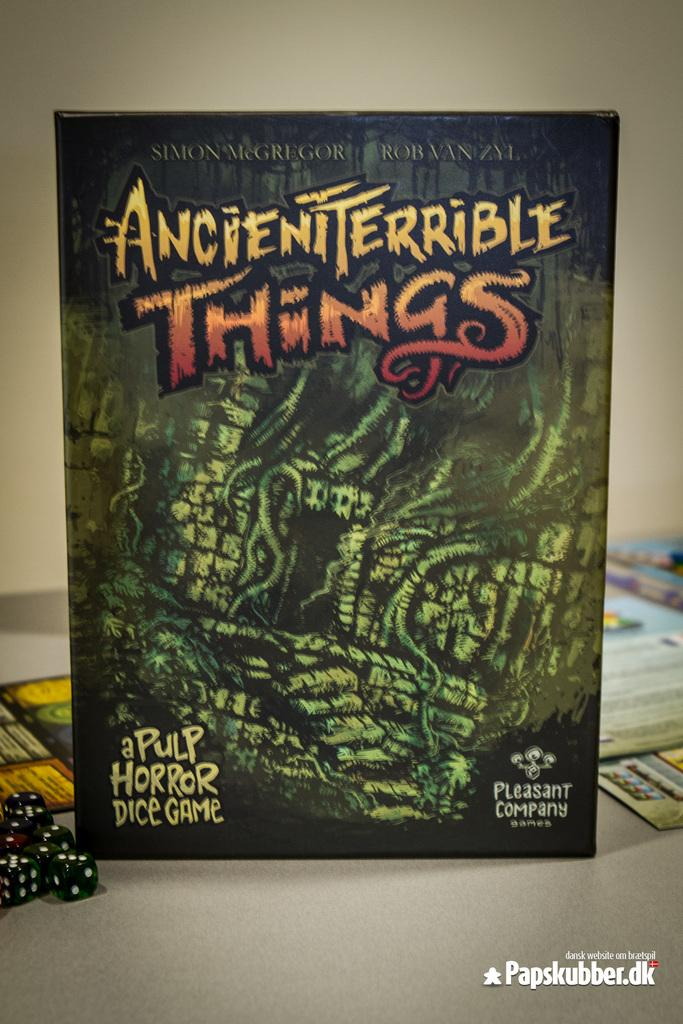<image>
Describe the image concisely. A close up of a game box which tells us it is a horror game called Ancient Terrible Things. 